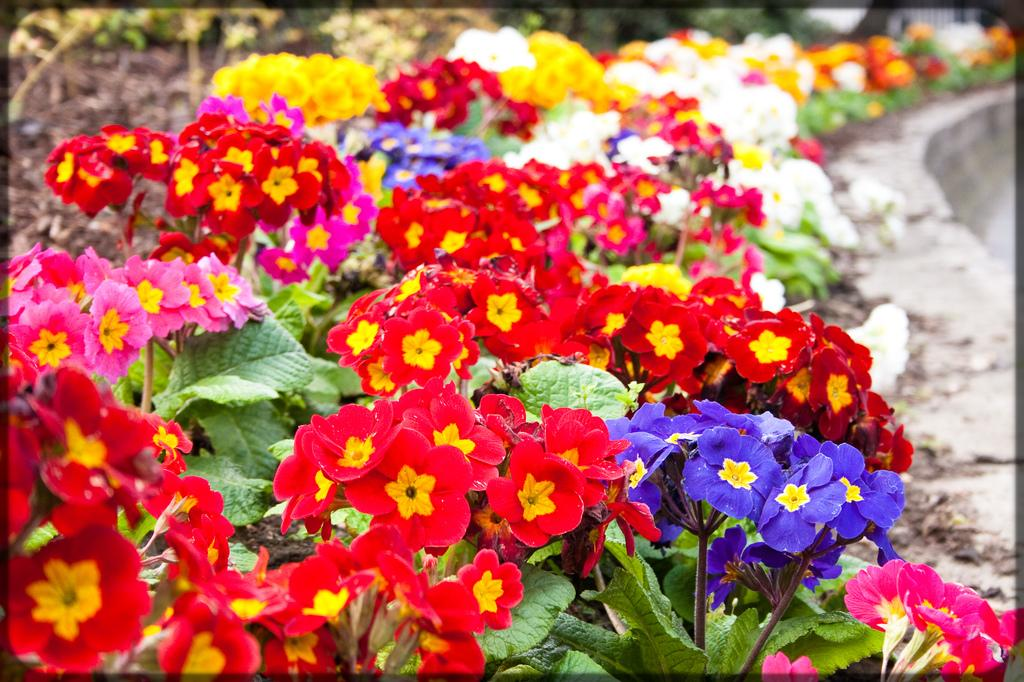What type of living organisms can be seen in the image? There are flowers and plants visible in the image. Can you describe the plants in the image? The plants in the image are not specified, but they are present alongside the flowers. What type of sock is hanging on the plant in the image? There is no sock present in the image; it only features flowers and plants. Where can the characters be seen having lunch in the image? There are no characters or lunchroom depicted in the image; it only contains flowers and plants. 